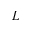<formula> <loc_0><loc_0><loc_500><loc_500>L</formula> 